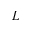<formula> <loc_0><loc_0><loc_500><loc_500>L</formula> 